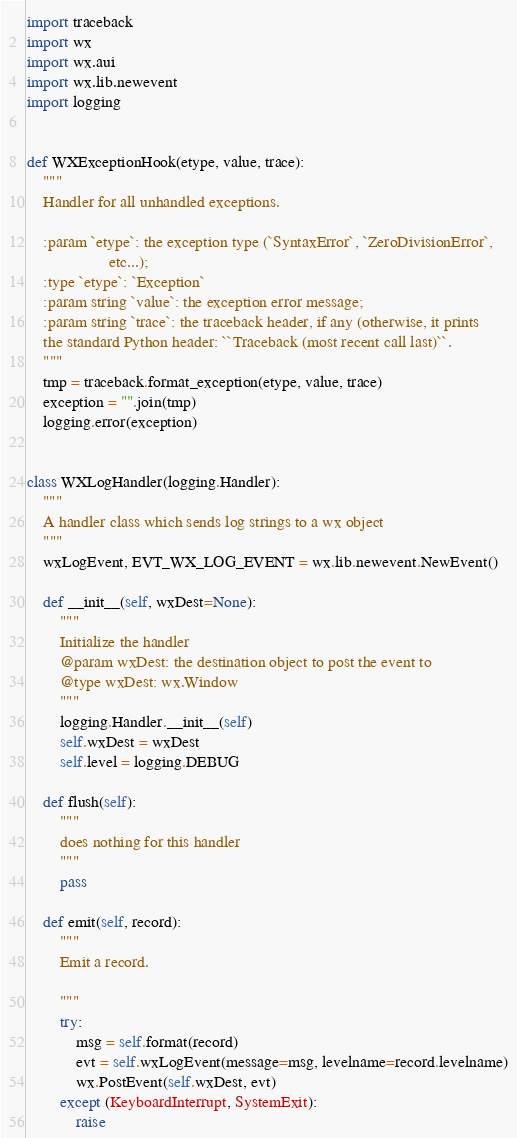<code> <loc_0><loc_0><loc_500><loc_500><_Python_>import traceback
import wx
import wx.aui
import wx.lib.newevent
import logging


def WXExceptionHook(etype, value, trace):
    """
    Handler for all unhandled exceptions.

    :param `etype`: the exception type (`SyntaxError`, `ZeroDivisionError`,
                    etc...);
    :type `etype`: `Exception`
    :param string `value`: the exception error message;
    :param string `trace`: the traceback header, if any (otherwise, it prints
    the standard Python header: ``Traceback (most recent call last)``.
    """
    tmp = traceback.format_exception(etype, value, trace)
    exception = "".join(tmp)
    logging.error(exception)


class WXLogHandler(logging.Handler):
    """
    A handler class which sends log strings to a wx object
    """
    wxLogEvent, EVT_WX_LOG_EVENT = wx.lib.newevent.NewEvent()

    def __init__(self, wxDest=None):
        """
        Initialize the handler
        @param wxDest: the destination object to post the event to
        @type wxDest: wx.Window
        """
        logging.Handler.__init__(self)
        self.wxDest = wxDest
        self.level = logging.DEBUG

    def flush(self):
        """
        does nothing for this handler
        """
        pass

    def emit(self, record):
        """
        Emit a record.

        """
        try:
            msg = self.format(record)
            evt = self.wxLogEvent(message=msg, levelname=record.levelname)
            wx.PostEvent(self.wxDest, evt)
        except (KeyboardInterrupt, SystemExit):
            raise

</code> 